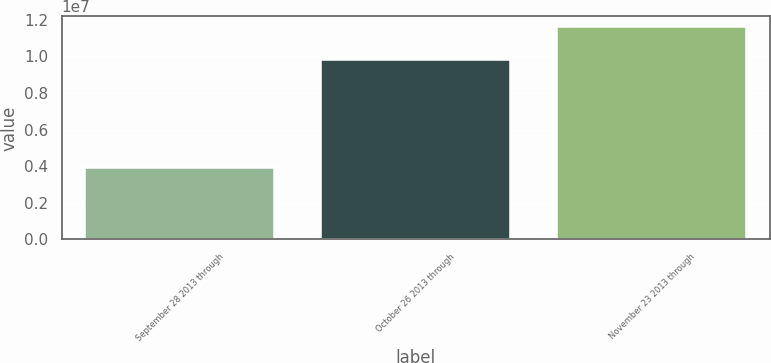<chart> <loc_0><loc_0><loc_500><loc_500><bar_chart><fcel>September 28 2013 through<fcel>October 26 2013 through<fcel>November 23 2013 through<nl><fcel>3.88e+06<fcel>9.7955e+06<fcel>1.16093e+07<nl></chart> 